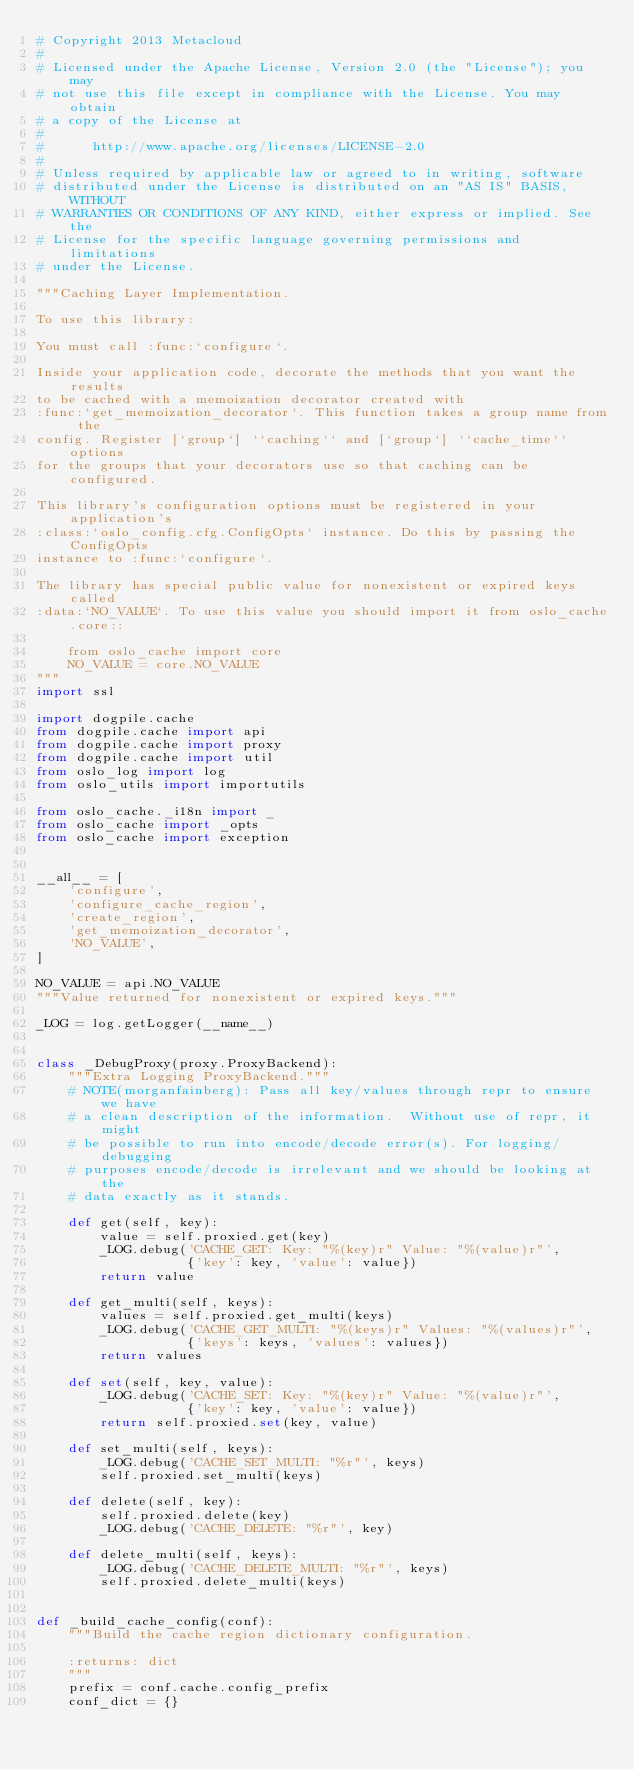Convert code to text. <code><loc_0><loc_0><loc_500><loc_500><_Python_># Copyright 2013 Metacloud
#
# Licensed under the Apache License, Version 2.0 (the "License"); you may
# not use this file except in compliance with the License. You may obtain
# a copy of the License at
#
#      http://www.apache.org/licenses/LICENSE-2.0
#
# Unless required by applicable law or agreed to in writing, software
# distributed under the License is distributed on an "AS IS" BASIS, WITHOUT
# WARRANTIES OR CONDITIONS OF ANY KIND, either express or implied. See the
# License for the specific language governing permissions and limitations
# under the License.

"""Caching Layer Implementation.

To use this library:

You must call :func:`configure`.

Inside your application code, decorate the methods that you want the results
to be cached with a memoization decorator created with
:func:`get_memoization_decorator`. This function takes a group name from the
config. Register [`group`] ``caching`` and [`group`] ``cache_time`` options
for the groups that your decorators use so that caching can be configured.

This library's configuration options must be registered in your application's
:class:`oslo_config.cfg.ConfigOpts` instance. Do this by passing the ConfigOpts
instance to :func:`configure`.

The library has special public value for nonexistent or expired keys called
:data:`NO_VALUE`. To use this value you should import it from oslo_cache.core::

    from oslo_cache import core
    NO_VALUE = core.NO_VALUE
"""
import ssl

import dogpile.cache
from dogpile.cache import api
from dogpile.cache import proxy
from dogpile.cache import util
from oslo_log import log
from oslo_utils import importutils

from oslo_cache._i18n import _
from oslo_cache import _opts
from oslo_cache import exception


__all__ = [
    'configure',
    'configure_cache_region',
    'create_region',
    'get_memoization_decorator',
    'NO_VALUE',
]

NO_VALUE = api.NO_VALUE
"""Value returned for nonexistent or expired keys."""

_LOG = log.getLogger(__name__)


class _DebugProxy(proxy.ProxyBackend):
    """Extra Logging ProxyBackend."""
    # NOTE(morganfainberg): Pass all key/values through repr to ensure we have
    # a clean description of the information.  Without use of repr, it might
    # be possible to run into encode/decode error(s). For logging/debugging
    # purposes encode/decode is irrelevant and we should be looking at the
    # data exactly as it stands.

    def get(self, key):
        value = self.proxied.get(key)
        _LOG.debug('CACHE_GET: Key: "%(key)r" Value: "%(value)r"',
                   {'key': key, 'value': value})
        return value

    def get_multi(self, keys):
        values = self.proxied.get_multi(keys)
        _LOG.debug('CACHE_GET_MULTI: "%(keys)r" Values: "%(values)r"',
                   {'keys': keys, 'values': values})
        return values

    def set(self, key, value):
        _LOG.debug('CACHE_SET: Key: "%(key)r" Value: "%(value)r"',
                   {'key': key, 'value': value})
        return self.proxied.set(key, value)

    def set_multi(self, keys):
        _LOG.debug('CACHE_SET_MULTI: "%r"', keys)
        self.proxied.set_multi(keys)

    def delete(self, key):
        self.proxied.delete(key)
        _LOG.debug('CACHE_DELETE: "%r"', key)

    def delete_multi(self, keys):
        _LOG.debug('CACHE_DELETE_MULTI: "%r"', keys)
        self.proxied.delete_multi(keys)


def _build_cache_config(conf):
    """Build the cache region dictionary configuration.

    :returns: dict
    """
    prefix = conf.cache.config_prefix
    conf_dict = {}</code> 